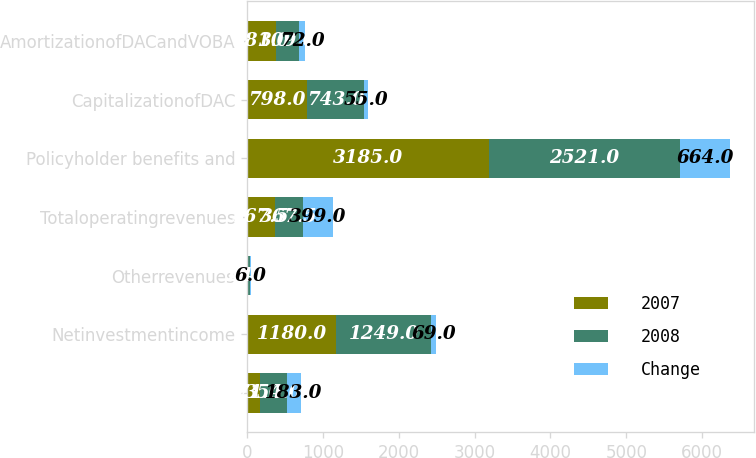<chart> <loc_0><loc_0><loc_500><loc_500><stacked_bar_chart><ecel><fcel>Unnamed: 1<fcel>Netinvestmentincome<fcel>Otherrevenues<fcel>Totaloperatingrevenues<fcel>Policyholder benefits and<fcel>CapitalizationofDAC<fcel>AmortizationofDACandVOBA<nl><fcel>2007<fcel>171<fcel>1180<fcel>18<fcel>367.5<fcel>3185<fcel>798<fcel>381<nl><fcel>2008<fcel>354<fcel>1249<fcel>24<fcel>367.5<fcel>2521<fcel>743<fcel>309<nl><fcel>Change<fcel>183<fcel>69<fcel>6<fcel>399<fcel>664<fcel>55<fcel>72<nl></chart> 